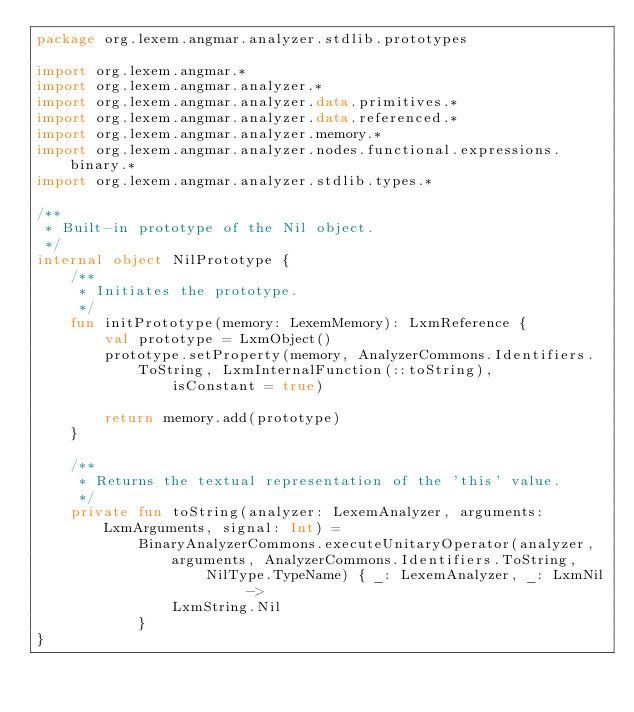Convert code to text. <code><loc_0><loc_0><loc_500><loc_500><_Kotlin_>package org.lexem.angmar.analyzer.stdlib.prototypes

import org.lexem.angmar.*
import org.lexem.angmar.analyzer.*
import org.lexem.angmar.analyzer.data.primitives.*
import org.lexem.angmar.analyzer.data.referenced.*
import org.lexem.angmar.analyzer.memory.*
import org.lexem.angmar.analyzer.nodes.functional.expressions.binary.*
import org.lexem.angmar.analyzer.stdlib.types.*

/**
 * Built-in prototype of the Nil object.
 */
internal object NilPrototype {
    /**
     * Initiates the prototype.
     */
    fun initPrototype(memory: LexemMemory): LxmReference {
        val prototype = LxmObject()
        prototype.setProperty(memory, AnalyzerCommons.Identifiers.ToString, LxmInternalFunction(::toString),
                isConstant = true)

        return memory.add(prototype)
    }

    /**
     * Returns the textual representation of the 'this' value.
     */
    private fun toString(analyzer: LexemAnalyzer, arguments: LxmArguments, signal: Int) =
            BinaryAnalyzerCommons.executeUnitaryOperator(analyzer, arguments, AnalyzerCommons.Identifiers.ToString,
                    NilType.TypeName) { _: LexemAnalyzer, _: LxmNil ->
                LxmString.Nil
            }
}
</code> 